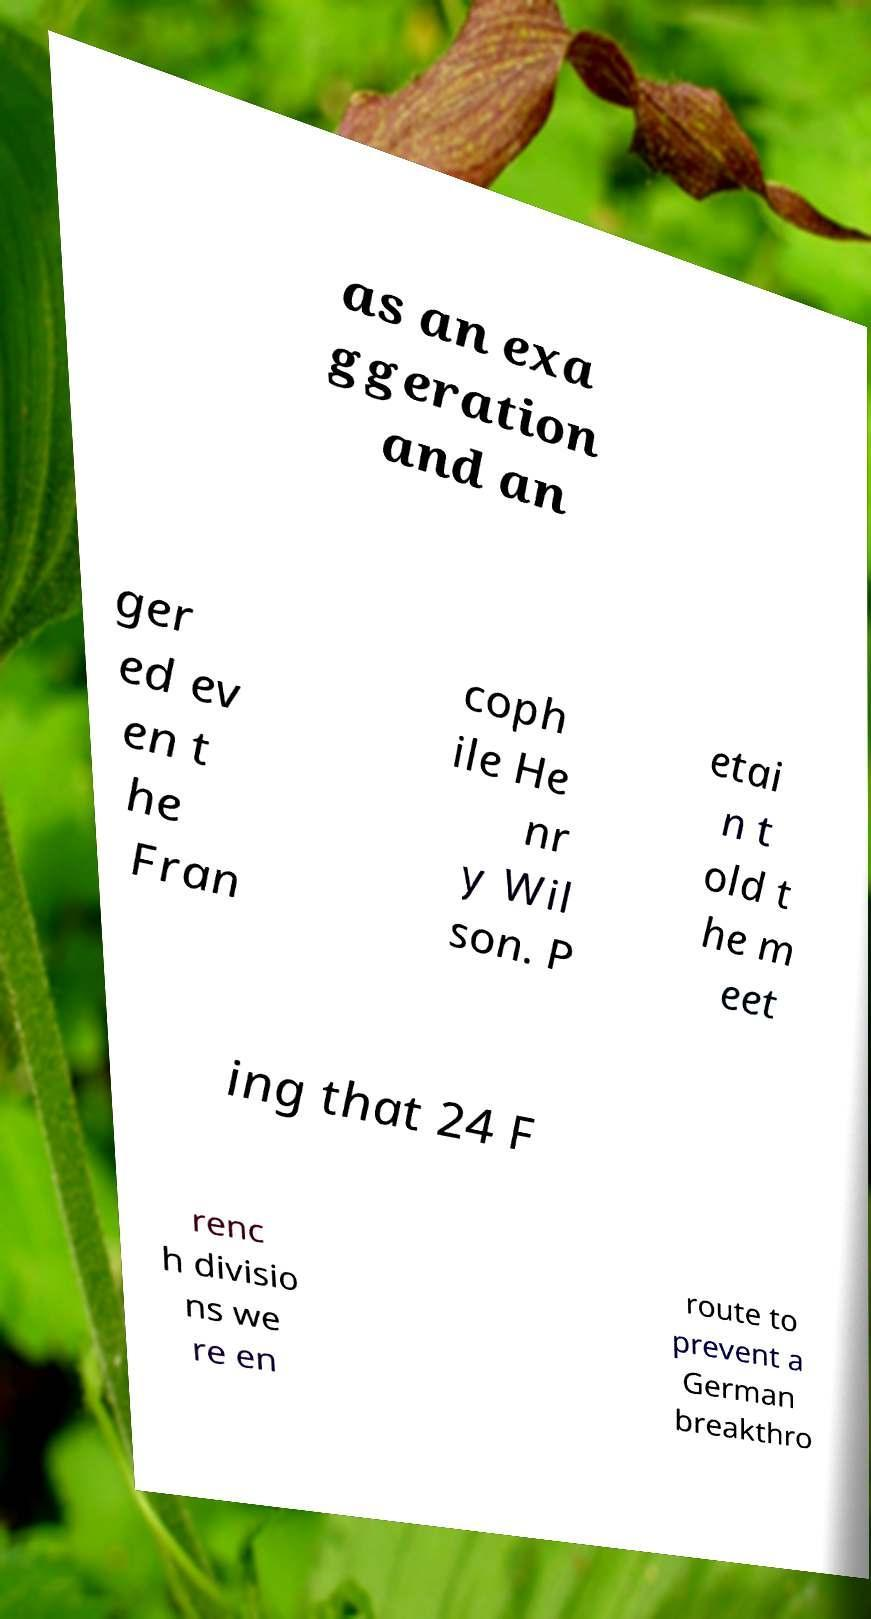Please identify and transcribe the text found in this image. as an exa ggeration and an ger ed ev en t he Fran coph ile He nr y Wil son. P etai n t old t he m eet ing that 24 F renc h divisio ns we re en route to prevent a German breakthro 